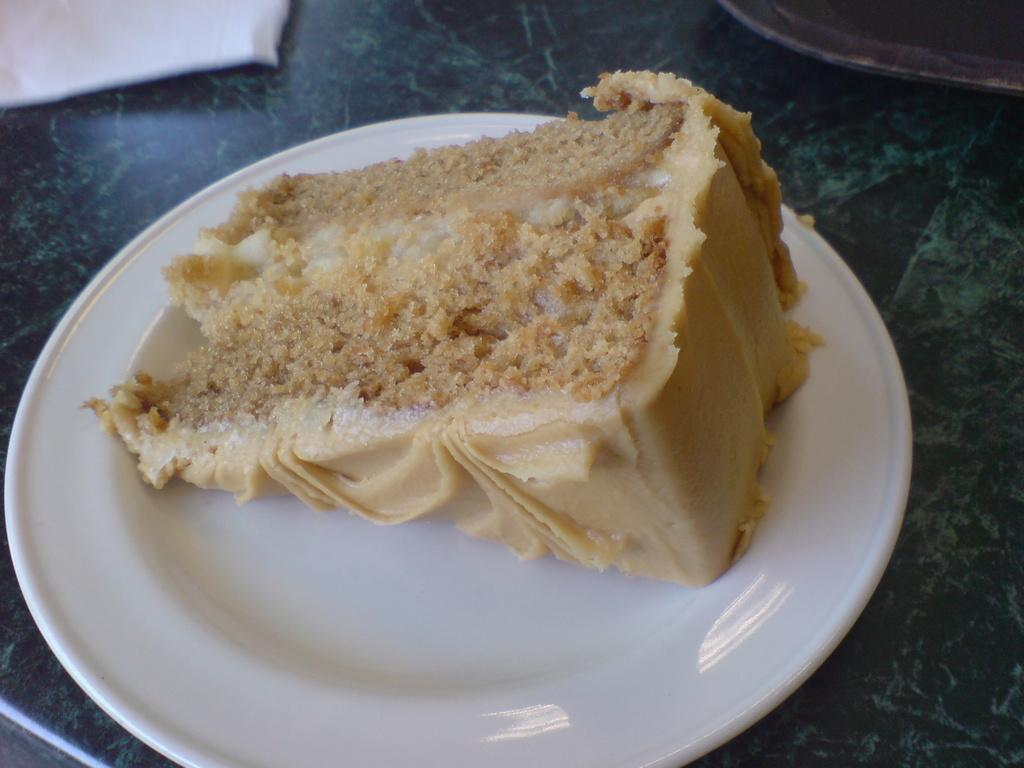In one or two sentences, can you explain what this image depicts? In this image we can see a piece of a cake in a white color plate. The plate is on the stone surface. We can see two objects at the top of the image. 